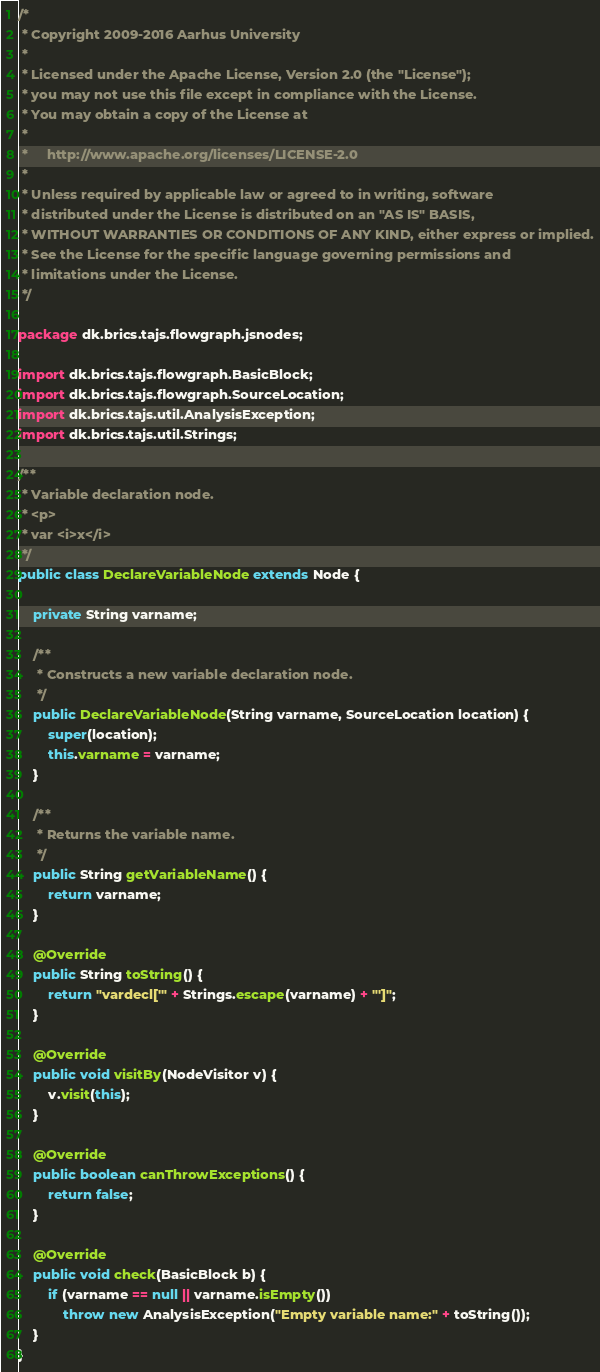<code> <loc_0><loc_0><loc_500><loc_500><_Java_>/*
 * Copyright 2009-2016 Aarhus University
 *
 * Licensed under the Apache License, Version 2.0 (the "License");
 * you may not use this file except in compliance with the License.
 * You may obtain a copy of the License at
 *
 *     http://www.apache.org/licenses/LICENSE-2.0
 *
 * Unless required by applicable law or agreed to in writing, software
 * distributed under the License is distributed on an "AS IS" BASIS,
 * WITHOUT WARRANTIES OR CONDITIONS OF ANY KIND, either express or implied.
 * See the License for the specific language governing permissions and
 * limitations under the License.
 */

package dk.brics.tajs.flowgraph.jsnodes;

import dk.brics.tajs.flowgraph.BasicBlock;
import dk.brics.tajs.flowgraph.SourceLocation;
import dk.brics.tajs.util.AnalysisException;
import dk.brics.tajs.util.Strings;

/**
 * Variable declaration node.
 * <p>
 * var <i>x</i>
 */
public class DeclareVariableNode extends Node {

    private String varname;

    /**
     * Constructs a new variable declaration node.
     */
    public DeclareVariableNode(String varname, SourceLocation location) {
        super(location);
        this.varname = varname;
    }

    /**
     * Returns the variable name.
     */
    public String getVariableName() {
        return varname;
    }

    @Override
    public String toString() {
        return "vardecl['" + Strings.escape(varname) + "']";
    }

    @Override
    public void visitBy(NodeVisitor v) {
        v.visit(this);
    }

    @Override
    public boolean canThrowExceptions() {
        return false;
    }

    @Override
    public void check(BasicBlock b) {
        if (varname == null || varname.isEmpty())
            throw new AnalysisException("Empty variable name:" + toString());
    }
}
</code> 